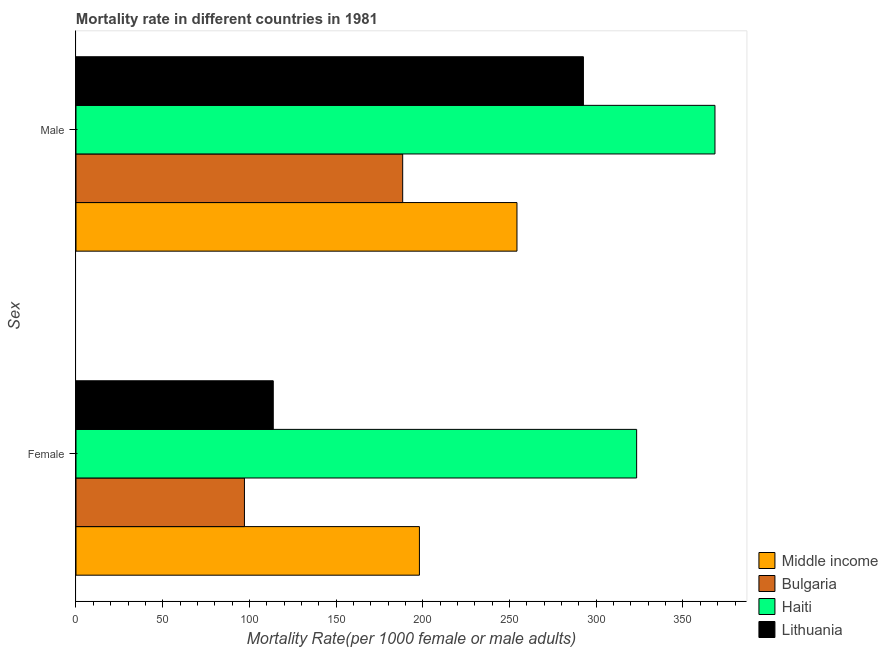How many different coloured bars are there?
Provide a succinct answer. 4. Are the number of bars on each tick of the Y-axis equal?
Offer a terse response. Yes. What is the female mortality rate in Lithuania?
Provide a short and direct response. 113.75. Across all countries, what is the maximum female mortality rate?
Your answer should be compact. 323.27. Across all countries, what is the minimum male mortality rate?
Your response must be concise. 188.38. In which country was the male mortality rate maximum?
Offer a very short reply. Haiti. What is the total female mortality rate in the graph?
Provide a short and direct response. 732.19. What is the difference between the male mortality rate in Lithuania and that in Haiti?
Offer a terse response. -75.85. What is the difference between the male mortality rate in Haiti and the female mortality rate in Bulgaria?
Keep it short and to the point. 271.31. What is the average female mortality rate per country?
Ensure brevity in your answer.  183.05. What is the difference between the male mortality rate and female mortality rate in Haiti?
Make the answer very short. 45.17. In how many countries, is the female mortality rate greater than 230 ?
Your response must be concise. 1. What is the ratio of the female mortality rate in Middle income to that in Haiti?
Offer a very short reply. 0.61. In how many countries, is the female mortality rate greater than the average female mortality rate taken over all countries?
Your answer should be compact. 2. What does the 4th bar from the bottom in Male represents?
Give a very brief answer. Lithuania. Are all the bars in the graph horizontal?
Keep it short and to the point. Yes. How many countries are there in the graph?
Provide a succinct answer. 4. What is the difference between two consecutive major ticks on the X-axis?
Keep it short and to the point. 50. Are the values on the major ticks of X-axis written in scientific E-notation?
Make the answer very short. No. Where does the legend appear in the graph?
Your response must be concise. Bottom right. How many legend labels are there?
Keep it short and to the point. 4. What is the title of the graph?
Make the answer very short. Mortality rate in different countries in 1981. Does "Iran" appear as one of the legend labels in the graph?
Give a very brief answer. No. What is the label or title of the X-axis?
Keep it short and to the point. Mortality Rate(per 1000 female or male adults). What is the label or title of the Y-axis?
Your answer should be very brief. Sex. What is the Mortality Rate(per 1000 female or male adults) in Middle income in Female?
Provide a succinct answer. 198.03. What is the Mortality Rate(per 1000 female or male adults) of Bulgaria in Female?
Give a very brief answer. 97.13. What is the Mortality Rate(per 1000 female or male adults) of Haiti in Female?
Your answer should be very brief. 323.27. What is the Mortality Rate(per 1000 female or male adults) of Lithuania in Female?
Your answer should be compact. 113.75. What is the Mortality Rate(per 1000 female or male adults) of Middle income in Male?
Your response must be concise. 254.28. What is the Mortality Rate(per 1000 female or male adults) of Bulgaria in Male?
Your answer should be very brief. 188.38. What is the Mortality Rate(per 1000 female or male adults) of Haiti in Male?
Keep it short and to the point. 368.44. What is the Mortality Rate(per 1000 female or male adults) in Lithuania in Male?
Offer a very short reply. 292.59. Across all Sex, what is the maximum Mortality Rate(per 1000 female or male adults) of Middle income?
Your answer should be very brief. 254.28. Across all Sex, what is the maximum Mortality Rate(per 1000 female or male adults) of Bulgaria?
Provide a succinct answer. 188.38. Across all Sex, what is the maximum Mortality Rate(per 1000 female or male adults) in Haiti?
Ensure brevity in your answer.  368.44. Across all Sex, what is the maximum Mortality Rate(per 1000 female or male adults) in Lithuania?
Offer a terse response. 292.59. Across all Sex, what is the minimum Mortality Rate(per 1000 female or male adults) in Middle income?
Offer a very short reply. 198.03. Across all Sex, what is the minimum Mortality Rate(per 1000 female or male adults) of Bulgaria?
Ensure brevity in your answer.  97.13. Across all Sex, what is the minimum Mortality Rate(per 1000 female or male adults) of Haiti?
Your response must be concise. 323.27. Across all Sex, what is the minimum Mortality Rate(per 1000 female or male adults) of Lithuania?
Your response must be concise. 113.75. What is the total Mortality Rate(per 1000 female or male adults) of Middle income in the graph?
Keep it short and to the point. 452.3. What is the total Mortality Rate(per 1000 female or male adults) of Bulgaria in the graph?
Offer a very short reply. 285.51. What is the total Mortality Rate(per 1000 female or male adults) of Haiti in the graph?
Your answer should be very brief. 691.72. What is the total Mortality Rate(per 1000 female or male adults) of Lithuania in the graph?
Offer a terse response. 406.34. What is the difference between the Mortality Rate(per 1000 female or male adults) in Middle income in Female and that in Male?
Make the answer very short. -56.25. What is the difference between the Mortality Rate(per 1000 female or male adults) in Bulgaria in Female and that in Male?
Give a very brief answer. -91.25. What is the difference between the Mortality Rate(per 1000 female or male adults) in Haiti in Female and that in Male?
Your answer should be compact. -45.16. What is the difference between the Mortality Rate(per 1000 female or male adults) of Lithuania in Female and that in Male?
Your response must be concise. -178.84. What is the difference between the Mortality Rate(per 1000 female or male adults) of Middle income in Female and the Mortality Rate(per 1000 female or male adults) of Bulgaria in Male?
Give a very brief answer. 9.65. What is the difference between the Mortality Rate(per 1000 female or male adults) in Middle income in Female and the Mortality Rate(per 1000 female or male adults) in Haiti in Male?
Make the answer very short. -170.41. What is the difference between the Mortality Rate(per 1000 female or male adults) of Middle income in Female and the Mortality Rate(per 1000 female or male adults) of Lithuania in Male?
Your response must be concise. -94.56. What is the difference between the Mortality Rate(per 1000 female or male adults) in Bulgaria in Female and the Mortality Rate(per 1000 female or male adults) in Haiti in Male?
Offer a very short reply. -271.31. What is the difference between the Mortality Rate(per 1000 female or male adults) of Bulgaria in Female and the Mortality Rate(per 1000 female or male adults) of Lithuania in Male?
Provide a succinct answer. -195.46. What is the difference between the Mortality Rate(per 1000 female or male adults) of Haiti in Female and the Mortality Rate(per 1000 female or male adults) of Lithuania in Male?
Your answer should be very brief. 30.68. What is the average Mortality Rate(per 1000 female or male adults) of Middle income per Sex?
Give a very brief answer. 226.15. What is the average Mortality Rate(per 1000 female or male adults) of Bulgaria per Sex?
Provide a short and direct response. 142.75. What is the average Mortality Rate(per 1000 female or male adults) in Haiti per Sex?
Keep it short and to the point. 345.86. What is the average Mortality Rate(per 1000 female or male adults) of Lithuania per Sex?
Give a very brief answer. 203.17. What is the difference between the Mortality Rate(per 1000 female or male adults) of Middle income and Mortality Rate(per 1000 female or male adults) of Bulgaria in Female?
Provide a short and direct response. 100.9. What is the difference between the Mortality Rate(per 1000 female or male adults) in Middle income and Mortality Rate(per 1000 female or male adults) in Haiti in Female?
Your answer should be compact. -125.25. What is the difference between the Mortality Rate(per 1000 female or male adults) of Middle income and Mortality Rate(per 1000 female or male adults) of Lithuania in Female?
Make the answer very short. 84.27. What is the difference between the Mortality Rate(per 1000 female or male adults) in Bulgaria and Mortality Rate(per 1000 female or male adults) in Haiti in Female?
Offer a terse response. -226.15. What is the difference between the Mortality Rate(per 1000 female or male adults) in Bulgaria and Mortality Rate(per 1000 female or male adults) in Lithuania in Female?
Keep it short and to the point. -16.62. What is the difference between the Mortality Rate(per 1000 female or male adults) in Haiti and Mortality Rate(per 1000 female or male adults) in Lithuania in Female?
Provide a short and direct response. 209.52. What is the difference between the Mortality Rate(per 1000 female or male adults) of Middle income and Mortality Rate(per 1000 female or male adults) of Bulgaria in Male?
Your answer should be compact. 65.89. What is the difference between the Mortality Rate(per 1000 female or male adults) of Middle income and Mortality Rate(per 1000 female or male adults) of Haiti in Male?
Provide a short and direct response. -114.16. What is the difference between the Mortality Rate(per 1000 female or male adults) of Middle income and Mortality Rate(per 1000 female or male adults) of Lithuania in Male?
Ensure brevity in your answer.  -38.31. What is the difference between the Mortality Rate(per 1000 female or male adults) of Bulgaria and Mortality Rate(per 1000 female or male adults) of Haiti in Male?
Keep it short and to the point. -180.06. What is the difference between the Mortality Rate(per 1000 female or male adults) of Bulgaria and Mortality Rate(per 1000 female or male adults) of Lithuania in Male?
Provide a short and direct response. -104.21. What is the difference between the Mortality Rate(per 1000 female or male adults) of Haiti and Mortality Rate(per 1000 female or male adults) of Lithuania in Male?
Your answer should be compact. 75.85. What is the ratio of the Mortality Rate(per 1000 female or male adults) in Middle income in Female to that in Male?
Provide a succinct answer. 0.78. What is the ratio of the Mortality Rate(per 1000 female or male adults) in Bulgaria in Female to that in Male?
Make the answer very short. 0.52. What is the ratio of the Mortality Rate(per 1000 female or male adults) of Haiti in Female to that in Male?
Provide a succinct answer. 0.88. What is the ratio of the Mortality Rate(per 1000 female or male adults) in Lithuania in Female to that in Male?
Offer a terse response. 0.39. What is the difference between the highest and the second highest Mortality Rate(per 1000 female or male adults) of Middle income?
Make the answer very short. 56.25. What is the difference between the highest and the second highest Mortality Rate(per 1000 female or male adults) of Bulgaria?
Give a very brief answer. 91.25. What is the difference between the highest and the second highest Mortality Rate(per 1000 female or male adults) in Haiti?
Offer a terse response. 45.16. What is the difference between the highest and the second highest Mortality Rate(per 1000 female or male adults) of Lithuania?
Your response must be concise. 178.84. What is the difference between the highest and the lowest Mortality Rate(per 1000 female or male adults) of Middle income?
Your answer should be compact. 56.25. What is the difference between the highest and the lowest Mortality Rate(per 1000 female or male adults) of Bulgaria?
Give a very brief answer. 91.25. What is the difference between the highest and the lowest Mortality Rate(per 1000 female or male adults) of Haiti?
Keep it short and to the point. 45.16. What is the difference between the highest and the lowest Mortality Rate(per 1000 female or male adults) of Lithuania?
Keep it short and to the point. 178.84. 